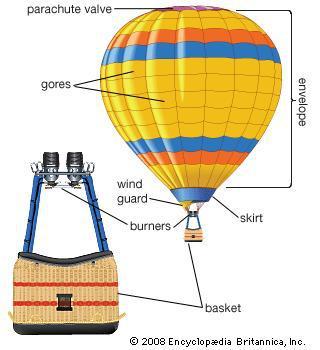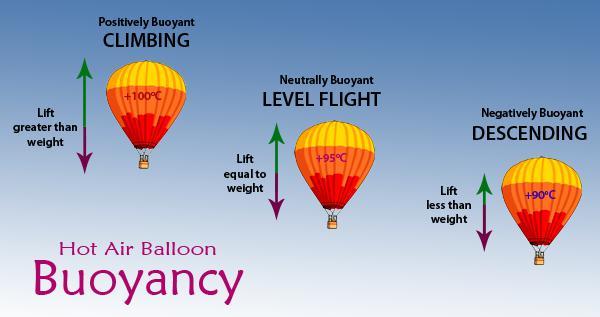The first image is the image on the left, the second image is the image on the right. Considering the images on both sides, is "An image shows the bright light of a flame inside a multi-colored hot-air balloon." valid? Answer yes or no. No. 